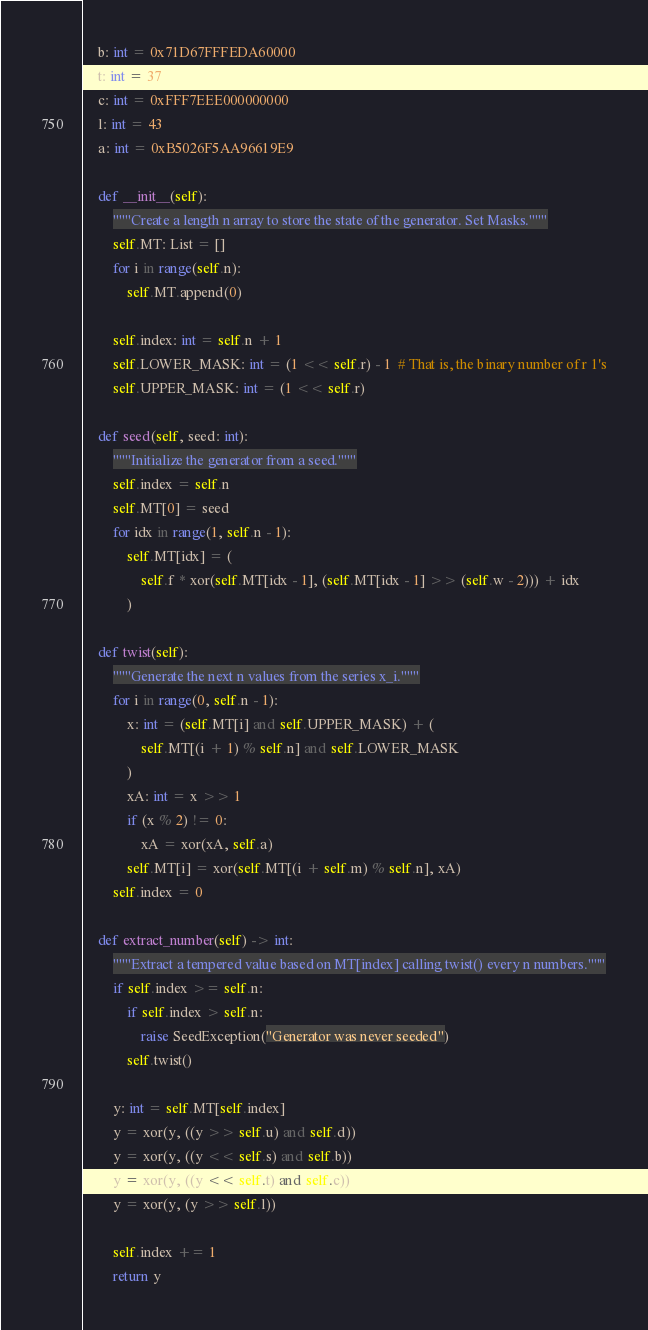<code> <loc_0><loc_0><loc_500><loc_500><_Python_>    b: int = 0x71D67FFFEDA60000
    t: int = 37
    c: int = 0xFFF7EEE000000000
    l: int = 43
    a: int = 0xB5026F5AA96619E9

    def __init__(self):
        """Create a length n array to store the state of the generator. Set Masks."""
        self.MT: List = []
        for i in range(self.n):
            self.MT.append(0)

        self.index: int = self.n + 1
        self.LOWER_MASK: int = (1 << self.r) - 1  # That is, the binary number of r 1's
        self.UPPER_MASK: int = (1 << self.r)

    def seed(self, seed: int):
        """Initialize the generator from a seed."""
        self.index = self.n
        self.MT[0] = seed
        for idx in range(1, self.n - 1):
            self.MT[idx] = (
                self.f * xor(self.MT[idx - 1], (self.MT[idx - 1] >> (self.w - 2))) + idx
            )

    def twist(self):
        """Generate the next n values from the series x_i."""
        for i in range(0, self.n - 1):
            x: int = (self.MT[i] and self.UPPER_MASK) + (
                self.MT[(i + 1) % self.n] and self.LOWER_MASK
            )
            xA: int = x >> 1
            if (x % 2) != 0:
                xA = xor(xA, self.a)
            self.MT[i] = xor(self.MT[(i + self.m) % self.n], xA)
        self.index = 0

    def extract_number(self) -> int:
        """Extract a tempered value based on MT[index] calling twist() every n numbers."""
        if self.index >= self.n:
            if self.index > self.n:
                raise SeedException("Generator was never seeded")
            self.twist()

        y: int = self.MT[self.index]
        y = xor(y, ((y >> self.u) and self.d))
        y = xor(y, ((y << self.s) and self.b))
        y = xor(y, ((y << self.t) and self.c))
        y = xor(y, (y >> self.l))

        self.index += 1
        return y
</code> 